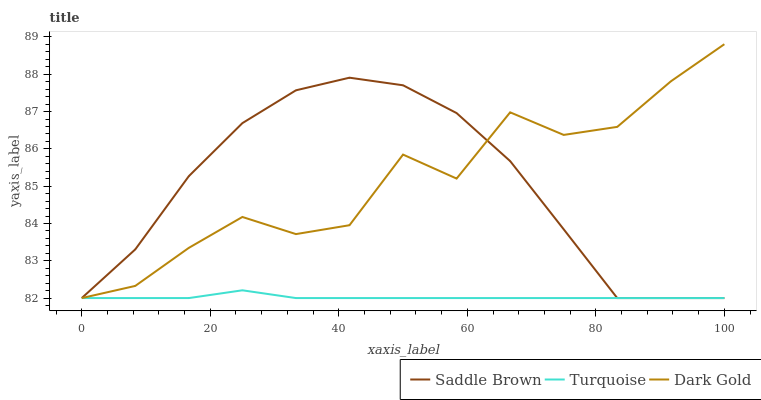Does Turquoise have the minimum area under the curve?
Answer yes or no. Yes. Does Dark Gold have the maximum area under the curve?
Answer yes or no. Yes. Does Saddle Brown have the minimum area under the curve?
Answer yes or no. No. Does Saddle Brown have the maximum area under the curve?
Answer yes or no. No. Is Turquoise the smoothest?
Answer yes or no. Yes. Is Dark Gold the roughest?
Answer yes or no. Yes. Is Saddle Brown the smoothest?
Answer yes or no. No. Is Saddle Brown the roughest?
Answer yes or no. No. Does Turquoise have the lowest value?
Answer yes or no. Yes. Does Dark Gold have the highest value?
Answer yes or no. Yes. Does Saddle Brown have the highest value?
Answer yes or no. No. Does Saddle Brown intersect Turquoise?
Answer yes or no. Yes. Is Saddle Brown less than Turquoise?
Answer yes or no. No. Is Saddle Brown greater than Turquoise?
Answer yes or no. No. 